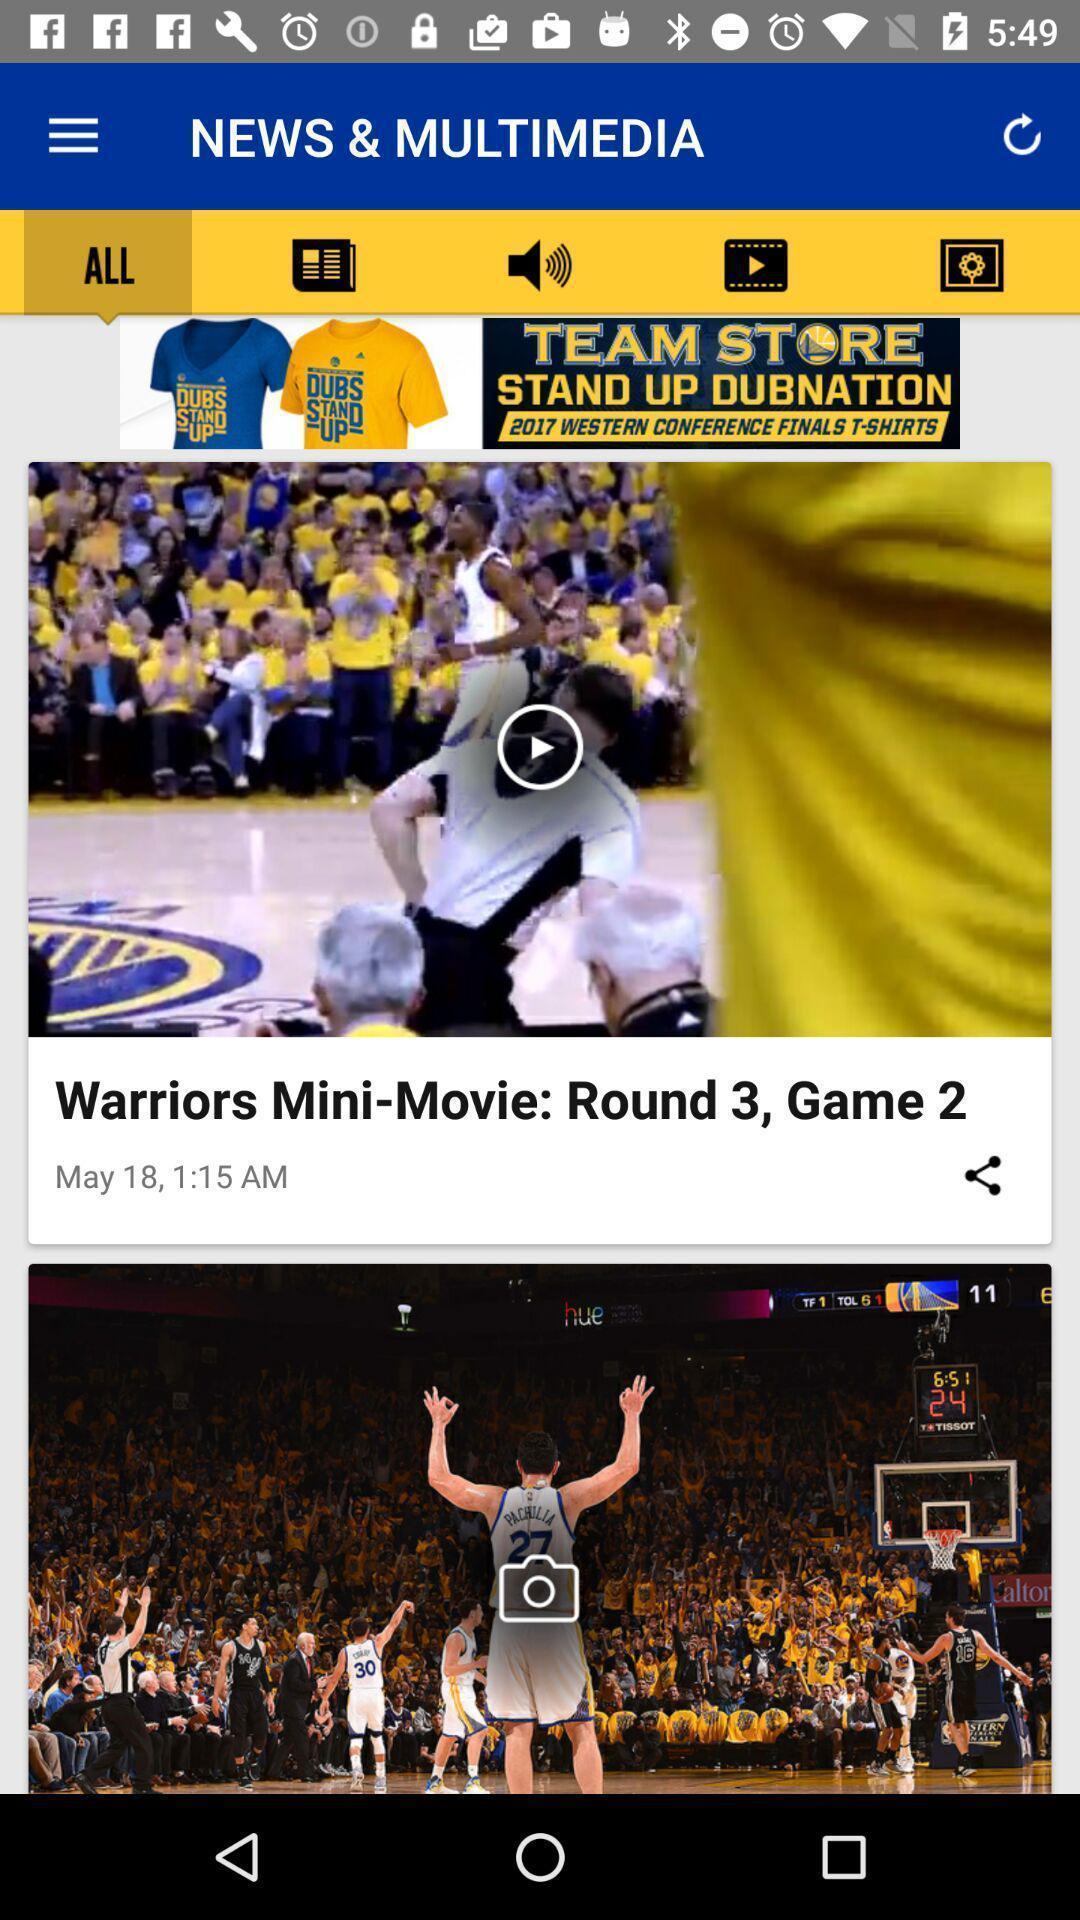Provide a textual representation of this image. Screen displaying video on a sports app. 